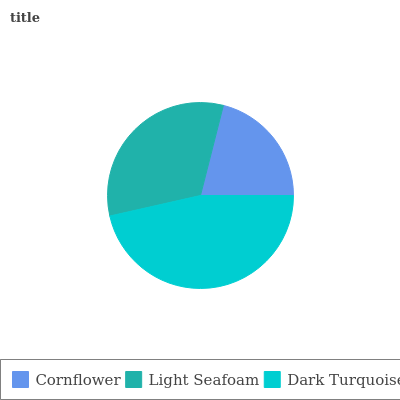Is Cornflower the minimum?
Answer yes or no. Yes. Is Dark Turquoise the maximum?
Answer yes or no. Yes. Is Light Seafoam the minimum?
Answer yes or no. No. Is Light Seafoam the maximum?
Answer yes or no. No. Is Light Seafoam greater than Cornflower?
Answer yes or no. Yes. Is Cornflower less than Light Seafoam?
Answer yes or no. Yes. Is Cornflower greater than Light Seafoam?
Answer yes or no. No. Is Light Seafoam less than Cornflower?
Answer yes or no. No. Is Light Seafoam the high median?
Answer yes or no. Yes. Is Light Seafoam the low median?
Answer yes or no. Yes. Is Dark Turquoise the high median?
Answer yes or no. No. Is Cornflower the low median?
Answer yes or no. No. 